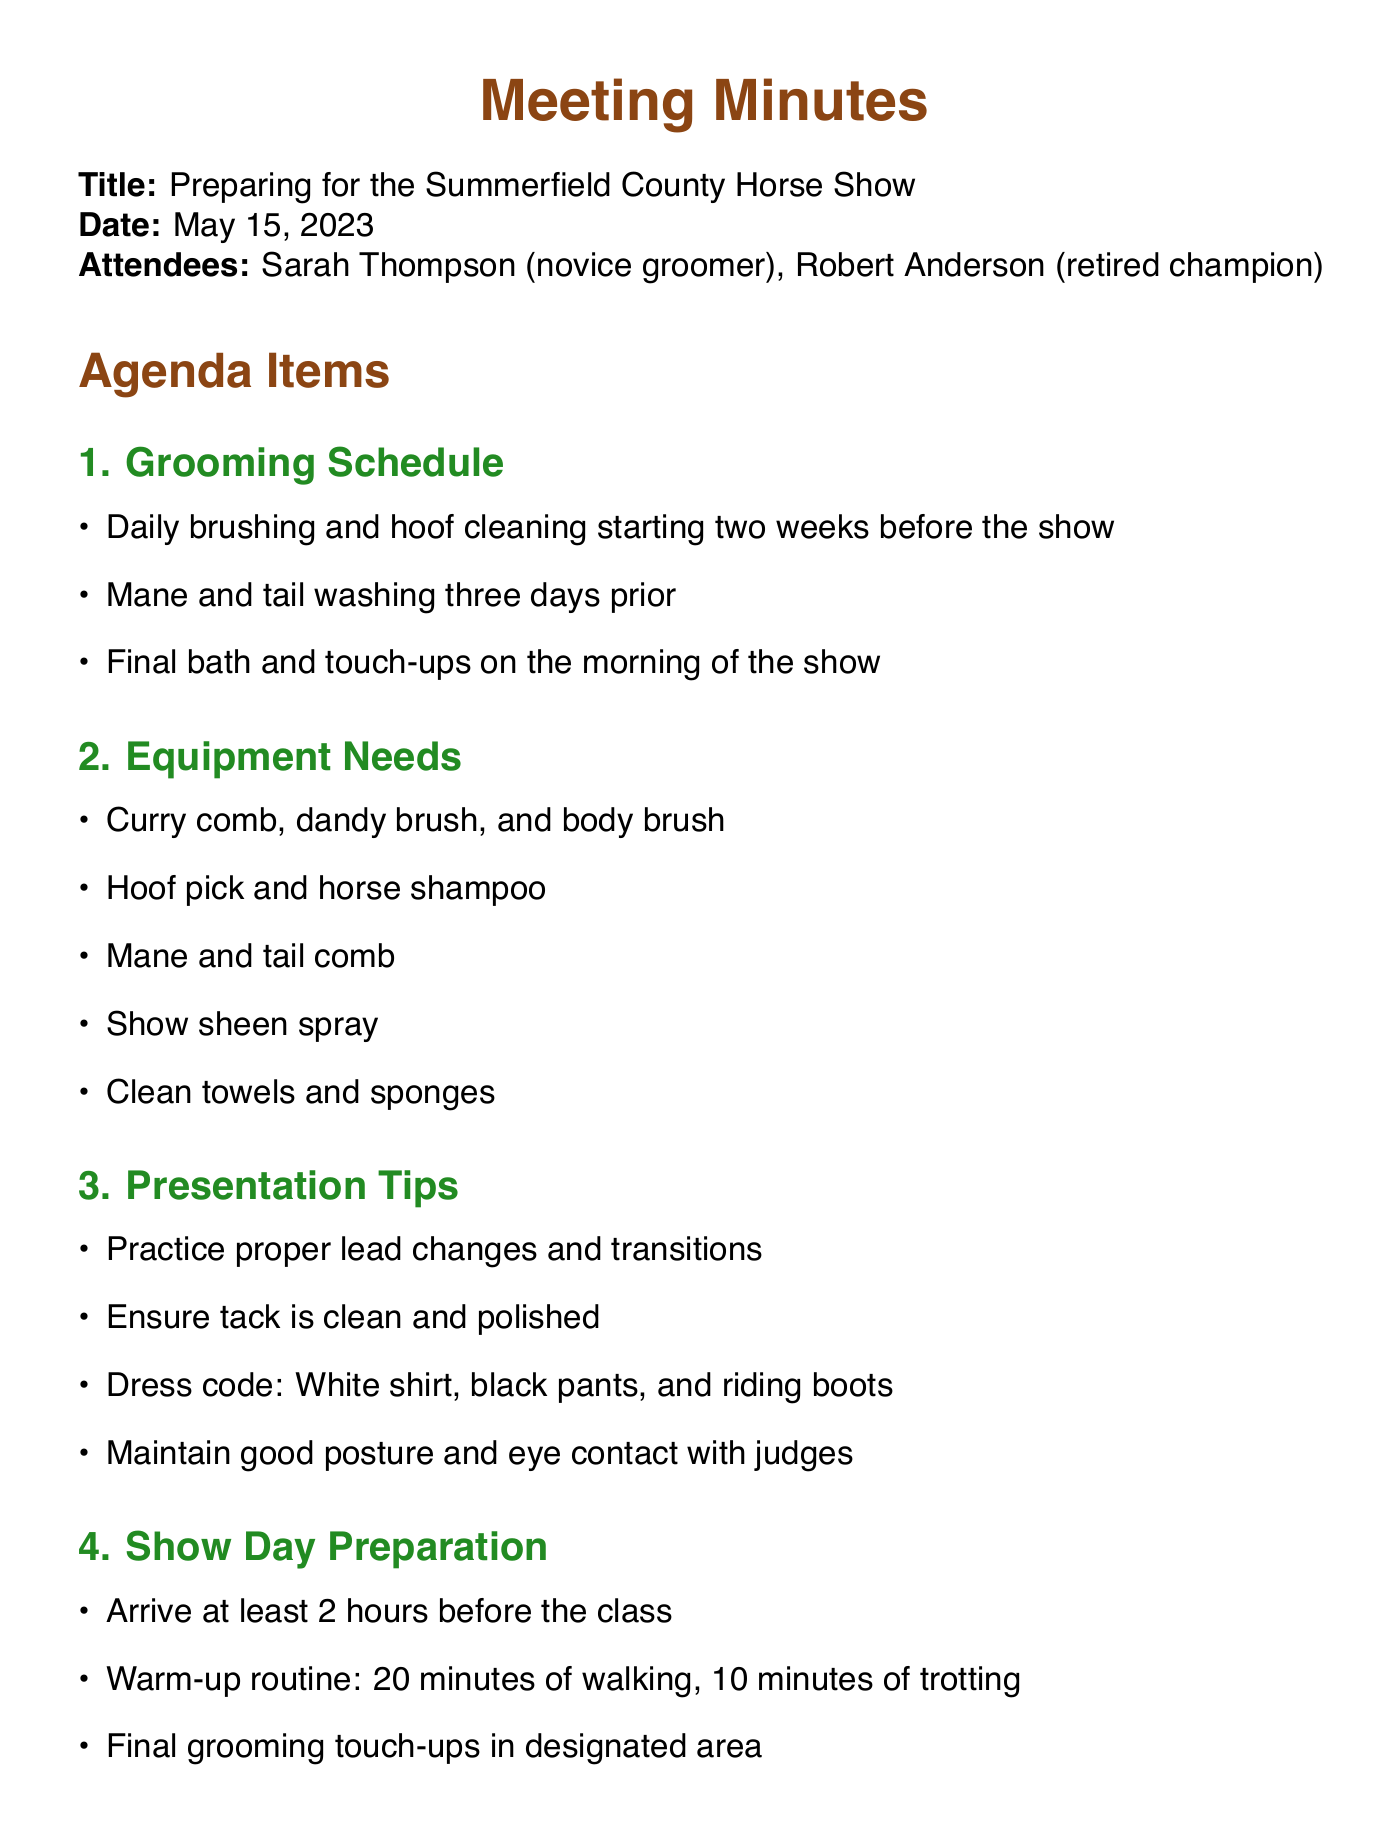What is the meeting title? The meeting title appears at the beginning of the document, it's discussed in the first line.
Answer: Preparing for the Summerfield County Horse Show Who is the retired champion? The document lists the attendees, which include Robert Anderson identified as the retired champion.
Answer: Robert Anderson What date is the next meeting? The next meeting date is explicitly mentioned towards the end of the document.
Answer: May 22, 2023 How long before the show should hoof cleaning start? The grooming schedule indicates that hoof cleaning should start two weeks before the show.
Answer: Two weeks What equipment items are needed for grooming? The equipment needs are listed under a specific agenda item and include multiple grooming items collectively.
Answer: Curry comb, dandy brush, and body brush What is one of the presentation tips? The presentation tips are clearly outlined in the document, showing the advice provided.
Answer: Maintain good posture and eye contact with judges How long should the warm-up routine be? The warm-up routine duration is specified in the show day preparation section of the document.
Answer: 30 minutes What is the first action item assigned to Sarah? The action items mention specific tasks assigned to attendees, with the first detail being assigned to Sarah.
Answer: Create a detailed grooming checklist What is the dress code for the show? The dress code is mentioned in the presentation tips section and indicates specific clothing requirements.
Answer: White shirt, black pants, and riding boots 